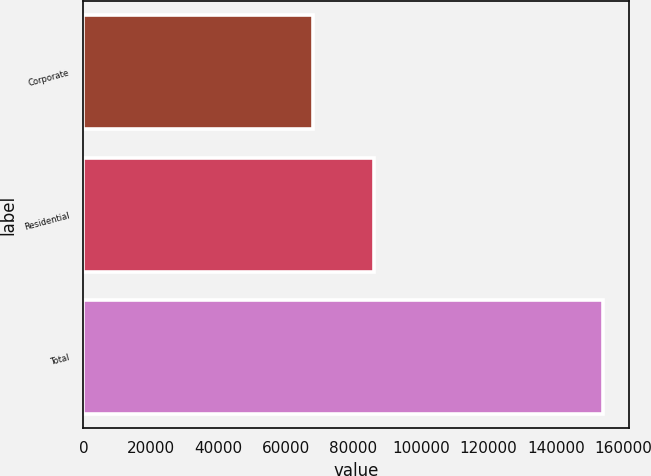<chart> <loc_0><loc_0><loc_500><loc_500><bar_chart><fcel>Corporate<fcel>Residential<fcel>Total<nl><fcel>67901<fcel>86082<fcel>153983<nl></chart> 